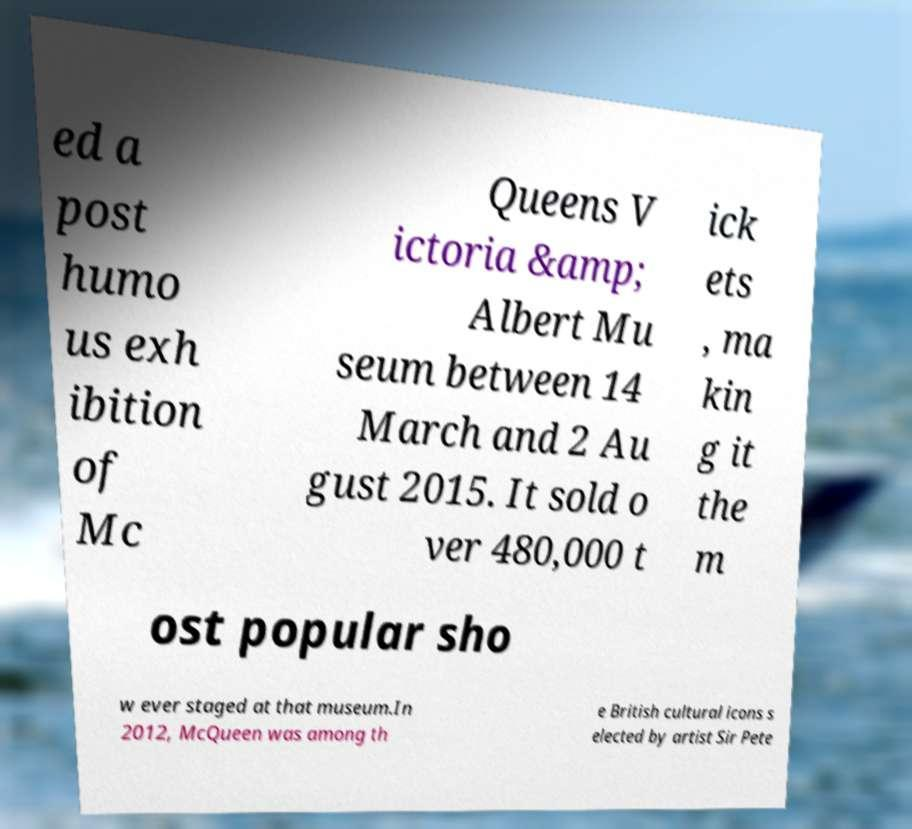There's text embedded in this image that I need extracted. Can you transcribe it verbatim? ed a post humo us exh ibition of Mc Queens V ictoria &amp; Albert Mu seum between 14 March and 2 Au gust 2015. It sold o ver 480,000 t ick ets , ma kin g it the m ost popular sho w ever staged at that museum.In 2012, McQueen was among th e British cultural icons s elected by artist Sir Pete 